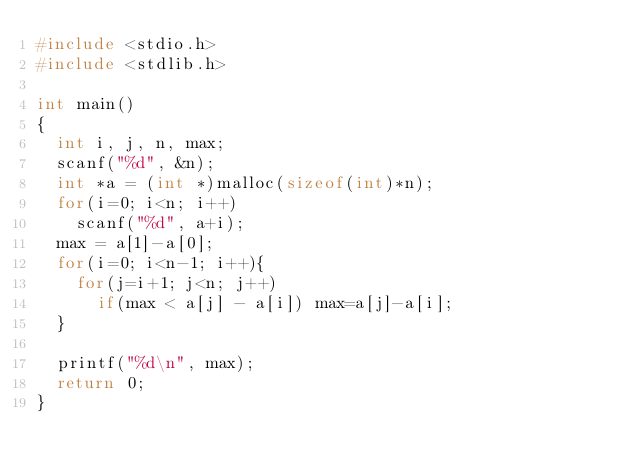<code> <loc_0><loc_0><loc_500><loc_500><_C_>#include <stdio.h>
#include <stdlib.h>

int main()
{
  int i, j, n, max;
  scanf("%d", &n);
  int *a = (int *)malloc(sizeof(int)*n);
  for(i=0; i<n; i++)
    scanf("%d", a+i);
  max = a[1]-a[0];
  for(i=0; i<n-1; i++){
    for(j=i+1; j<n; j++)
      if(max < a[j] - a[i]) max=a[j]-a[i];
  }

  printf("%d\n", max);
  return 0;
}</code> 